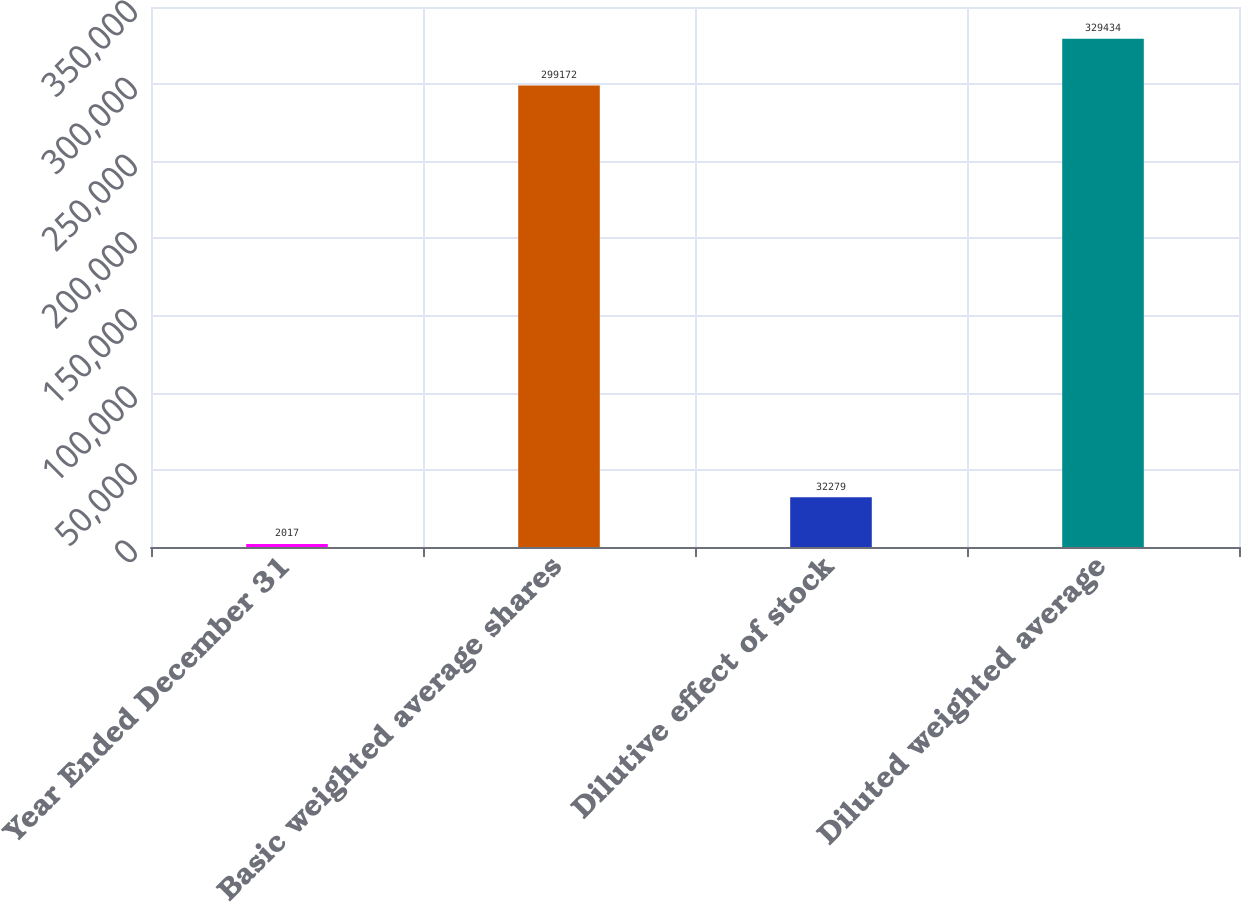Convert chart. <chart><loc_0><loc_0><loc_500><loc_500><bar_chart><fcel>Year Ended December 31<fcel>Basic weighted average shares<fcel>Dilutive effect of stock<fcel>Diluted weighted average<nl><fcel>2017<fcel>299172<fcel>32279<fcel>329434<nl></chart> 